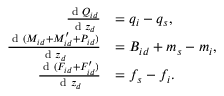Convert formula to latex. <formula><loc_0><loc_0><loc_500><loc_500>\begin{array} { r l } { \frac { d Q _ { i d } } { d z _ { d } } } & { = q _ { i } - q _ { s } , } \\ { \frac { d ( M _ { i d } + M _ { i d } ^ { \prime } + P _ { i d } ) } { d z _ { d } } } & { = B _ { i d } + m _ { s } - m _ { i } , } \\ { \frac { d ( F _ { i d } + F _ { i d } ^ { \prime } ) } { d z _ { d } } } & { = f _ { s } - f _ { i } . } \end{array}</formula> 